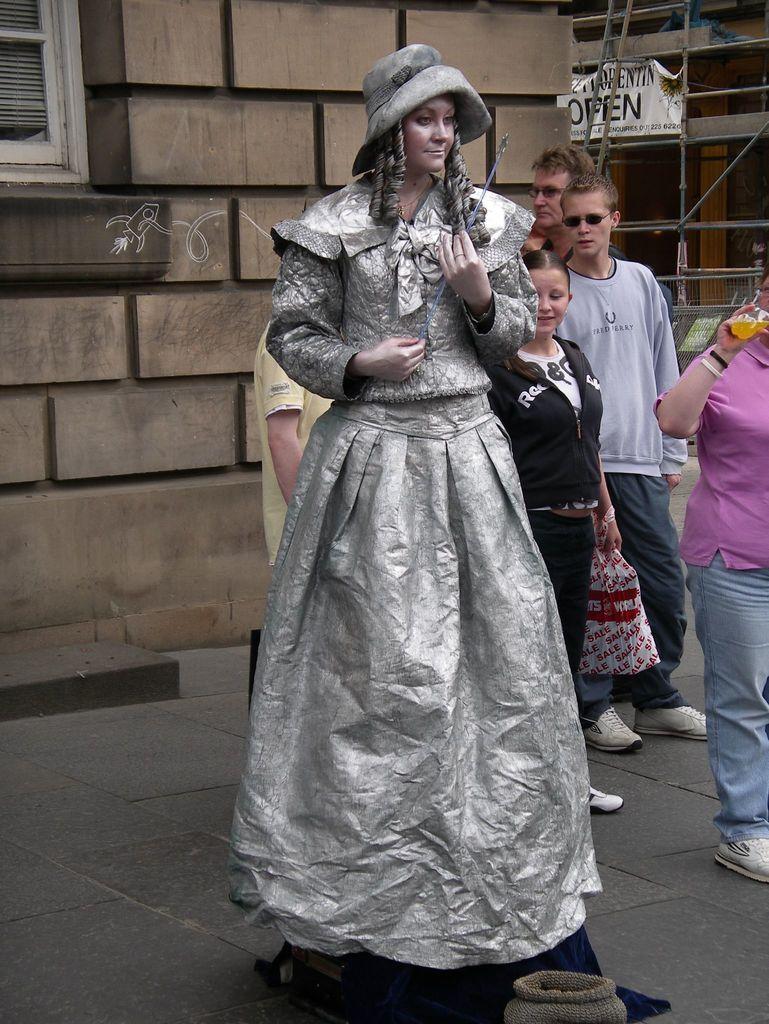In one or two sentences, can you explain what this image depicts? In this image there is a lady standing and she is in different costume, behind her there are a few people standing and staring at her, one of them is holding a drink in his hand, in front of the lady there is an object. In the background there are buildings. 